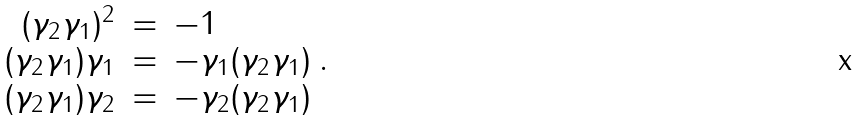Convert formula to latex. <formula><loc_0><loc_0><loc_500><loc_500>\begin{array} { r c l } ( \gamma _ { 2 } \gamma _ { 1 } ) ^ { 2 } & = & - 1 \\ ( \gamma _ { 2 } \gamma _ { 1 } ) \gamma _ { 1 } & = & - \gamma _ { 1 } ( \gamma _ { 2 } \gamma _ { 1 } ) \\ ( \gamma _ { 2 } \gamma _ { 1 } ) \gamma _ { 2 } & = & - \gamma _ { 2 } ( \gamma _ { 2 } \gamma _ { 1 } ) \end{array} .</formula> 